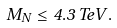<formula> <loc_0><loc_0><loc_500><loc_500>M _ { N } \leq 4 . 3 \, T e V .</formula> 